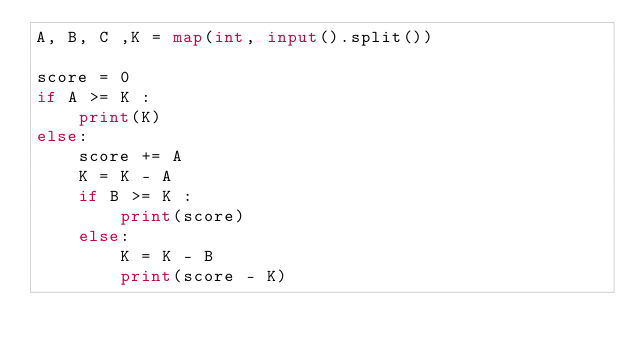Convert code to text. <code><loc_0><loc_0><loc_500><loc_500><_Python_>A, B, C ,K = map(int, input().split())

score = 0
if A >= K :
    print(K)
else:
    score += A
    K = K - A
    if B >= K :
        print(score)
    else:
        K = K - B
        print(score - K)</code> 